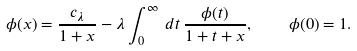<formula> <loc_0><loc_0><loc_500><loc_500>\phi ( x ) = \frac { c _ { \lambda } } { 1 + x } - \lambda \int _ { 0 } ^ { \infty } \, d t \, \frac { \phi ( t ) } { 1 + t + x } , \quad \phi ( 0 ) = 1 .</formula> 